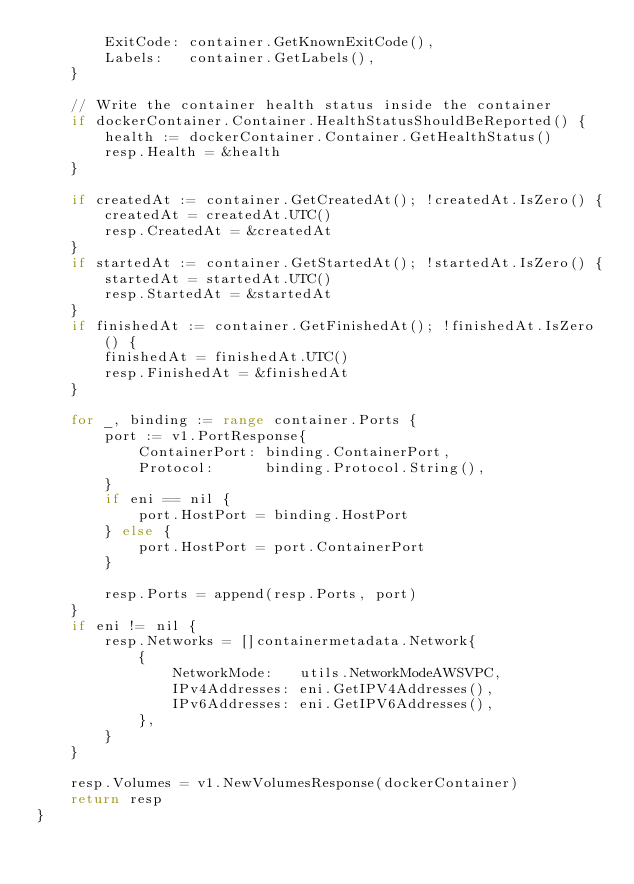Convert code to text. <code><loc_0><loc_0><loc_500><loc_500><_Go_>		ExitCode: container.GetKnownExitCode(),
		Labels:   container.GetLabels(),
	}

	// Write the container health status inside the container
	if dockerContainer.Container.HealthStatusShouldBeReported() {
		health := dockerContainer.Container.GetHealthStatus()
		resp.Health = &health
	}

	if createdAt := container.GetCreatedAt(); !createdAt.IsZero() {
		createdAt = createdAt.UTC()
		resp.CreatedAt = &createdAt
	}
	if startedAt := container.GetStartedAt(); !startedAt.IsZero() {
		startedAt = startedAt.UTC()
		resp.StartedAt = &startedAt
	}
	if finishedAt := container.GetFinishedAt(); !finishedAt.IsZero() {
		finishedAt = finishedAt.UTC()
		resp.FinishedAt = &finishedAt
	}

	for _, binding := range container.Ports {
		port := v1.PortResponse{
			ContainerPort: binding.ContainerPort,
			Protocol:      binding.Protocol.String(),
		}
		if eni == nil {
			port.HostPort = binding.HostPort
		} else {
			port.HostPort = port.ContainerPort
		}

		resp.Ports = append(resp.Ports, port)
	}
	if eni != nil {
		resp.Networks = []containermetadata.Network{
			{
				NetworkMode:   utils.NetworkModeAWSVPC,
				IPv4Addresses: eni.GetIPV4Addresses(),
				IPv6Addresses: eni.GetIPV6Addresses(),
			},
		}
	}

	resp.Volumes = v1.NewVolumesResponse(dockerContainer)
	return resp
}
</code> 